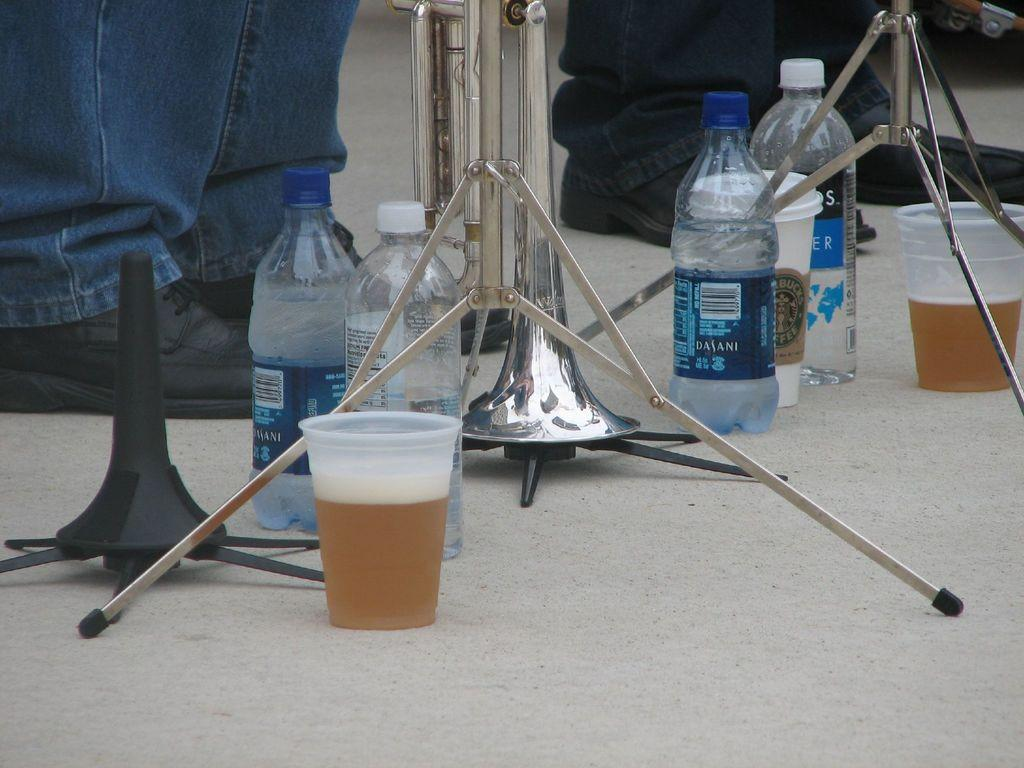<image>
Create a compact narrative representing the image presented. Bottles of Dasani sit on the floor next to other cups. 